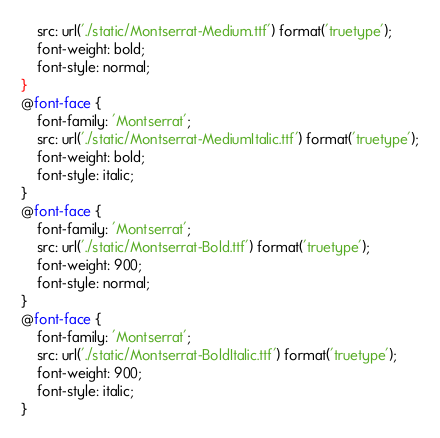<code> <loc_0><loc_0><loc_500><loc_500><_CSS_>    src: url('./static/Montserrat-Medium.ttf') format('truetype');
    font-weight: bold;
    font-style: normal;
}
@font-face {
    font-family: 'Montserrat';
    src: url('./static/Montserrat-MediumItalic.ttf') format('truetype');
    font-weight: bold;
    font-style: italic;
}
@font-face {
    font-family: 'Montserrat';
    src: url('./static/Montserrat-Bold.ttf') format('truetype');
    font-weight: 900;
    font-style: normal;
}
@font-face {
    font-family: 'Montserrat';
    src: url('./static/Montserrat-BoldItalic.ttf') format('truetype');
    font-weight: 900;
    font-style: italic;
}
</code> 